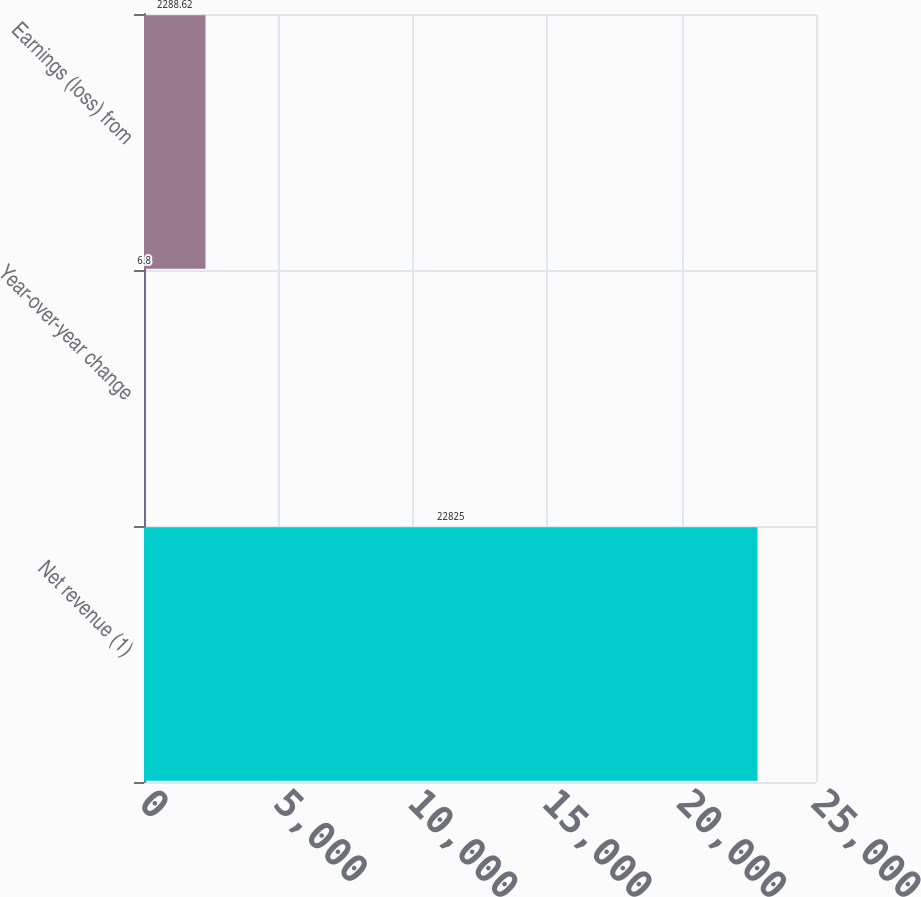<chart> <loc_0><loc_0><loc_500><loc_500><bar_chart><fcel>Net revenue (1)<fcel>Year-over-year change<fcel>Earnings (loss) from<nl><fcel>22825<fcel>6.8<fcel>2288.62<nl></chart> 